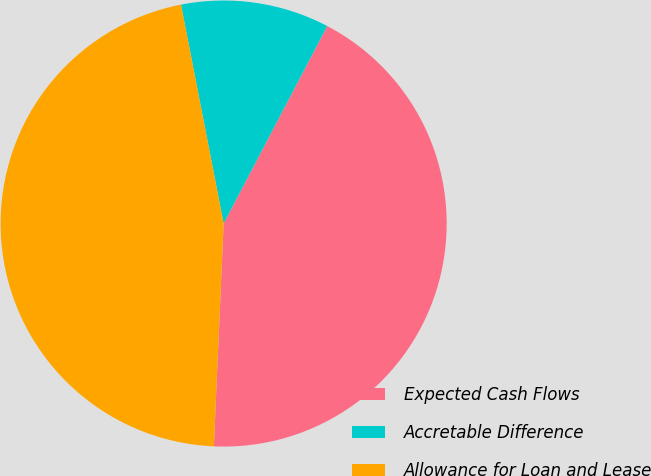<chart> <loc_0><loc_0><loc_500><loc_500><pie_chart><fcel>Expected Cash Flows<fcel>Accretable Difference<fcel>Allowance for Loan and Lease<nl><fcel>43.01%<fcel>10.75%<fcel>46.24%<nl></chart> 